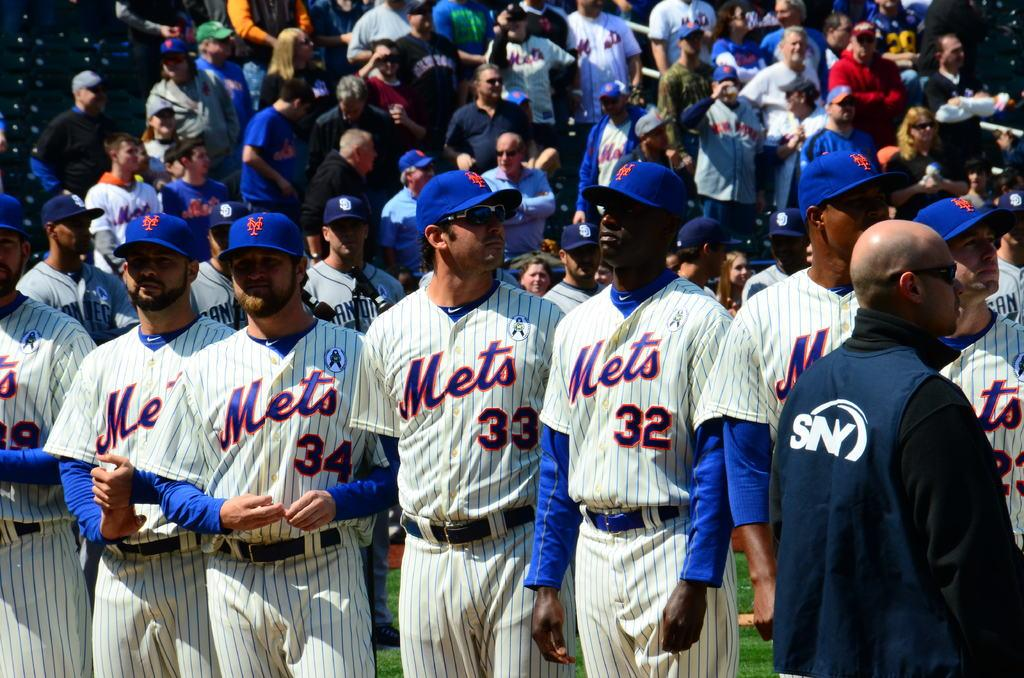<image>
Describe the image concisely. The new york mets lined up for the start of a game 